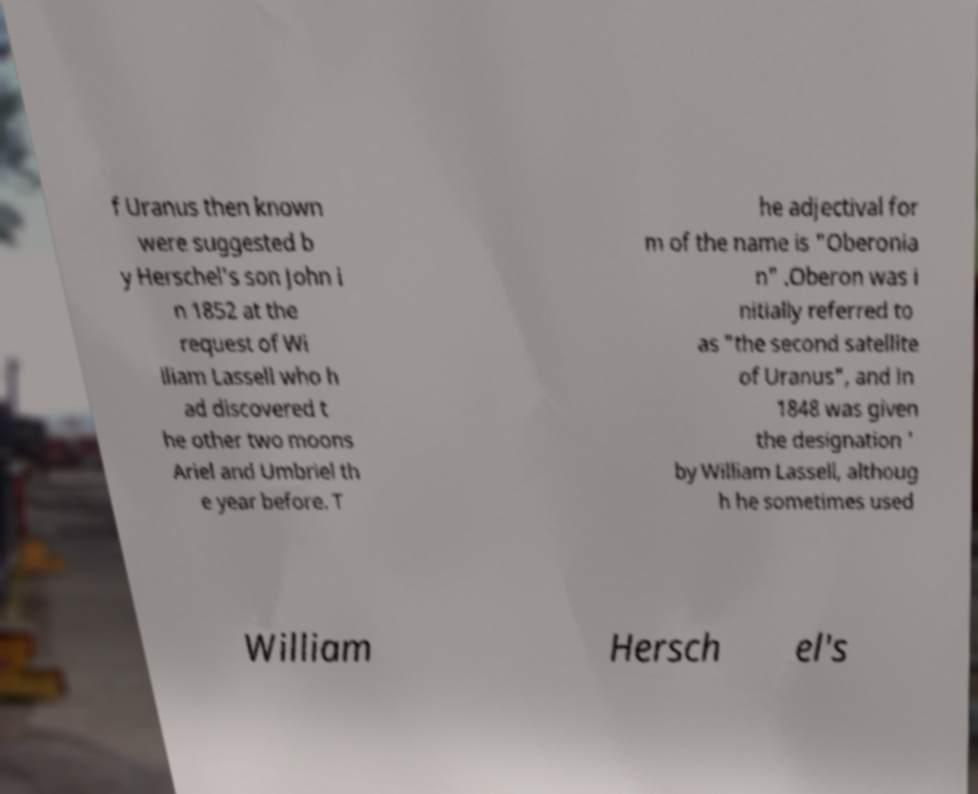For documentation purposes, I need the text within this image transcribed. Could you provide that? f Uranus then known were suggested b y Herschel's son John i n 1852 at the request of Wi lliam Lassell who h ad discovered t he other two moons Ariel and Umbriel th e year before. T he adjectival for m of the name is "Oberonia n" .Oberon was i nitially referred to as "the second satellite of Uranus", and in 1848 was given the designation ' by William Lassell, althoug h he sometimes used William Hersch el's 